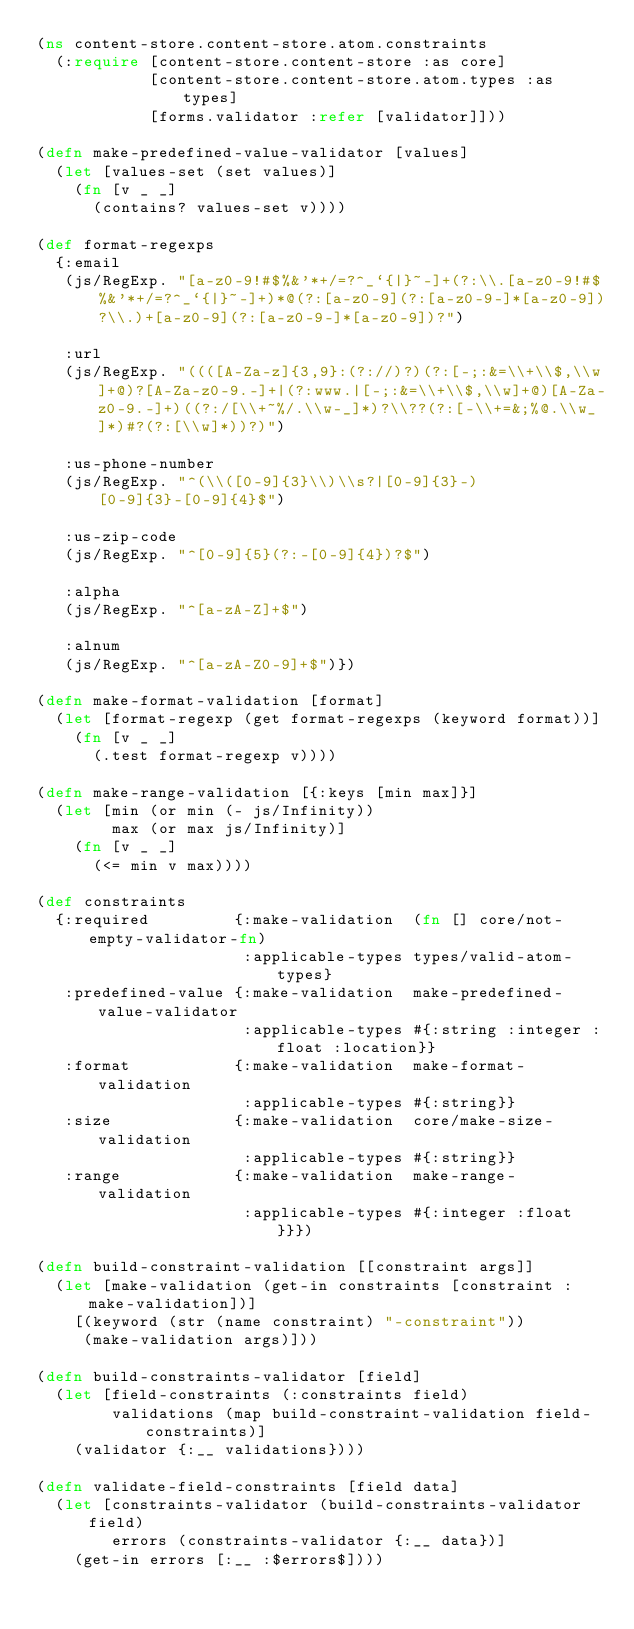<code> <loc_0><loc_0><loc_500><loc_500><_Clojure_>(ns content-store.content-store.atom.constraints
  (:require [content-store.content-store :as core]
            [content-store.content-store.atom.types :as types]
            [forms.validator :refer [validator]]))

(defn make-predefined-value-validator [values]
  (let [values-set (set values)]
    (fn [v _ _]
      (contains? values-set v))))

(def format-regexps
  {:email
   (js/RegExp. "[a-z0-9!#$%&'*+/=?^_`{|}~-]+(?:\\.[a-z0-9!#$%&'*+/=?^_`{|}~-]+)*@(?:[a-z0-9](?:[a-z0-9-]*[a-z0-9])?\\.)+[a-z0-9](?:[a-z0-9-]*[a-z0-9])?")

   :url
   (js/RegExp. "((([A-Za-z]{3,9}:(?://)?)(?:[-;:&=\\+\\$,\\w]+@)?[A-Za-z0-9.-]+|(?:www.|[-;:&=\\+\\$,\\w]+@)[A-Za-z0-9.-]+)((?:/[\\+~%/.\\w-_]*)?\\??(?:[-\\+=&;%@.\\w_]*)#?(?:[\\w]*))?)")

   :us-phone-number
   (js/RegExp. "^(\\([0-9]{3}\\)\\s?|[0-9]{3}-)[0-9]{3}-[0-9]{4}$")

   :us-zip-code
   (js/RegExp. "^[0-9]{5}(?:-[0-9]{4})?$")

   :alpha
   (js/RegExp. "^[a-zA-Z]+$")

   :alnum
   (js/RegExp. "^[a-zA-Z0-9]+$")})

(defn make-format-validation [format]
  (let [format-regexp (get format-regexps (keyword format))]
    (fn [v _ _]
      (.test format-regexp v))))

(defn make-range-validation [{:keys [min max]}]
  (let [min (or min (- js/Infinity))
        max (or max js/Infinity)]
    (fn [v _ _]
      (<= min v max))))

(def constraints
  {:required         {:make-validation  (fn [] core/not-empty-validator-fn)
                      :applicable-types types/valid-atom-types}
   :predefined-value {:make-validation  make-predefined-value-validator
                      :applicable-types #{:string :integer :float :location}}
   :format           {:make-validation  make-format-validation
                      :applicable-types #{:string}}
   :size             {:make-validation  core/make-size-validation
                      :applicable-types #{:string}}
   :range            {:make-validation  make-range-validation
                      :applicable-types #{:integer :float}}})

(defn build-constraint-validation [[constraint args]]
  (let [make-validation (get-in constraints [constraint :make-validation])]
    [(keyword (str (name constraint) "-constraint"))
     (make-validation args)]))

(defn build-constraints-validator [field]
  (let [field-constraints (:constraints field)
        validations (map build-constraint-validation field-constraints)]
    (validator {:__ validations})))

(defn validate-field-constraints [field data]
  (let [constraints-validator (build-constraints-validator field)
        errors (constraints-validator {:__ data})]
    (get-in errors [:__ :$errors$])))
</code> 